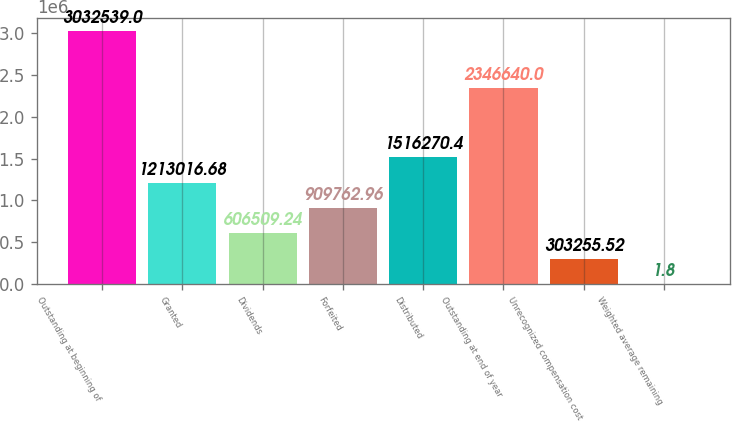Convert chart to OTSL. <chart><loc_0><loc_0><loc_500><loc_500><bar_chart><fcel>Outstanding at beginning of<fcel>Granted<fcel>Dividends<fcel>Forfeited<fcel>Distributed<fcel>Outstanding at end of year<fcel>Unrecognized compensation cost<fcel>Weighted average remaining<nl><fcel>3.03254e+06<fcel>1.21302e+06<fcel>606509<fcel>909763<fcel>1.51627e+06<fcel>2.34664e+06<fcel>303256<fcel>1.8<nl></chart> 